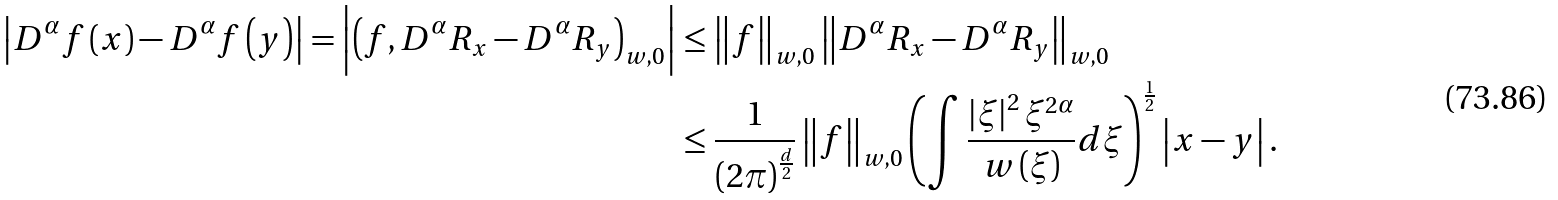Convert formula to latex. <formula><loc_0><loc_0><loc_500><loc_500>\left | D ^ { \alpha } f \left ( x \right ) - D ^ { \alpha } f \left ( y \right ) \right | = \left | \left ( f , D ^ { \alpha } R _ { x } - D ^ { \alpha } R _ { y } \right ) _ { w , 0 } \right | & \leq \left \| f \right \| _ { w , 0 } \left \| D ^ { \alpha } R _ { x } - D ^ { \alpha } R _ { y } \right \| _ { w , 0 } \\ & \leq \frac { 1 } { \left ( 2 \pi \right ) ^ { \frac { d } { 2 } } } \left \| f \right \| _ { w , 0 } \left ( \int \frac { \left | \xi \right | ^ { 2 } \xi ^ { 2 \alpha } } { w \left ( \xi \right ) } d \xi \right ) ^ { \frac { 1 } { 2 } } \left | x - y \right | .</formula> 